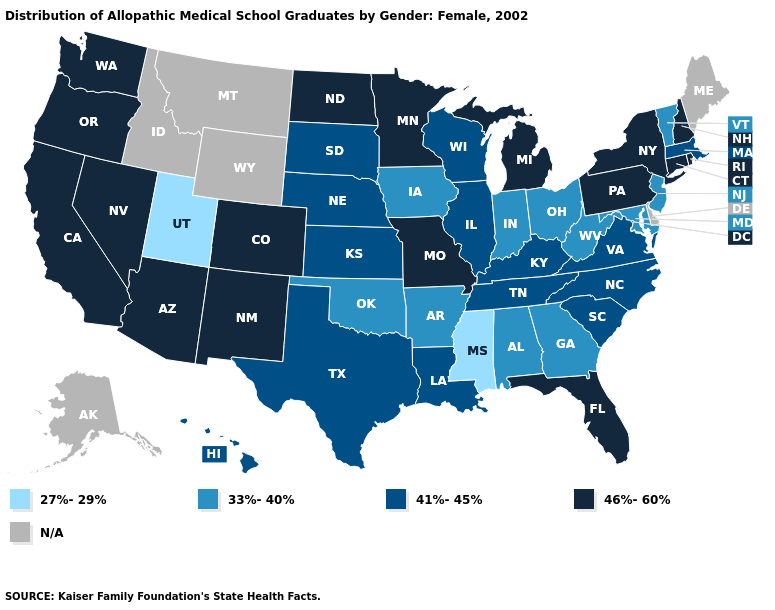Which states hav the highest value in the South?
Short answer required. Florida. Which states have the lowest value in the USA?
Concise answer only. Mississippi, Utah. Name the states that have a value in the range 41%-45%?
Give a very brief answer. Hawaii, Illinois, Kansas, Kentucky, Louisiana, Massachusetts, Nebraska, North Carolina, South Carolina, South Dakota, Tennessee, Texas, Virginia, Wisconsin. What is the value of Connecticut?
Keep it brief. 46%-60%. What is the value of Iowa?
Short answer required. 33%-40%. Does the map have missing data?
Give a very brief answer. Yes. Does the first symbol in the legend represent the smallest category?
Answer briefly. Yes. Does Mississippi have the lowest value in the USA?
Concise answer only. Yes. What is the value of Hawaii?
Keep it brief. 41%-45%. Is the legend a continuous bar?
Concise answer only. No. What is the highest value in the MidWest ?
Quick response, please. 46%-60%. Name the states that have a value in the range N/A?
Quick response, please. Alaska, Delaware, Idaho, Maine, Montana, Wyoming. What is the highest value in the Northeast ?
Short answer required. 46%-60%. What is the highest value in the USA?
Write a very short answer. 46%-60%. 